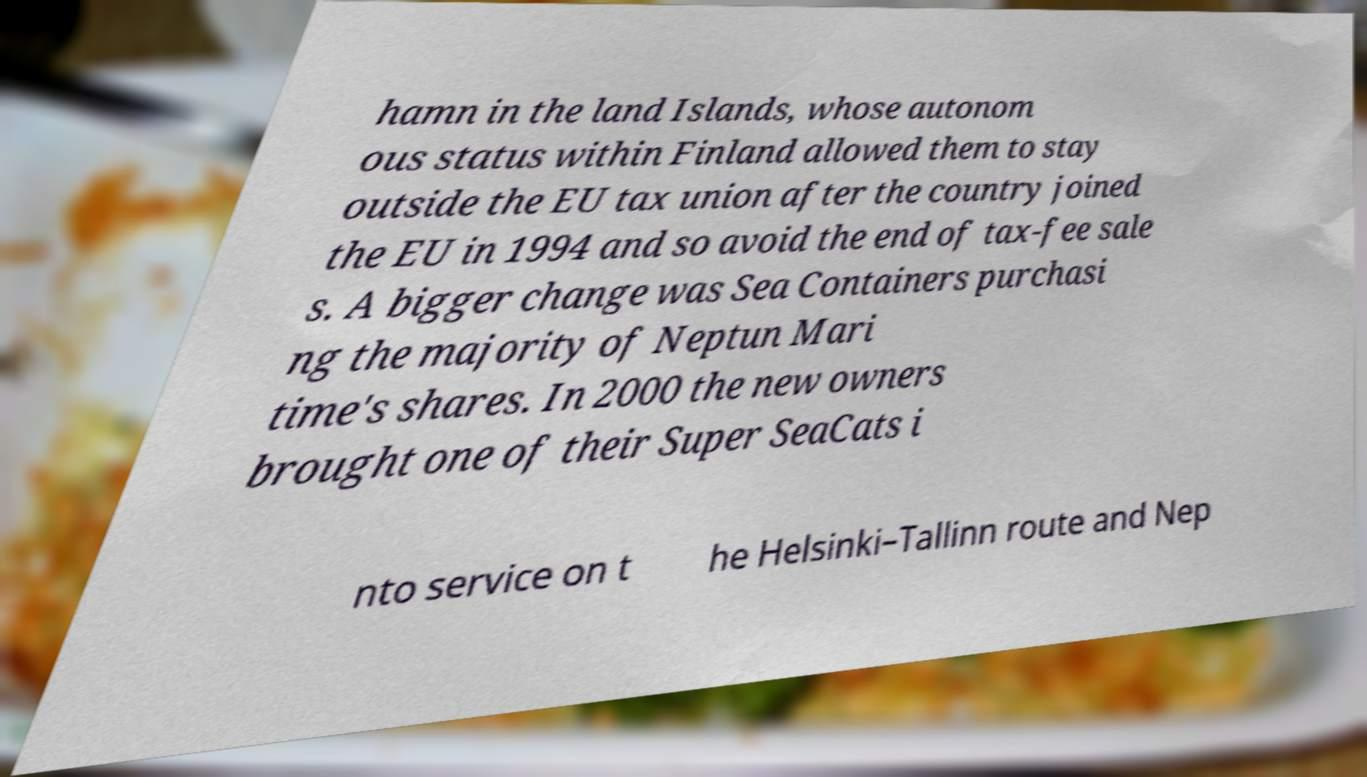Please read and relay the text visible in this image. What does it say? hamn in the land Islands, whose autonom ous status within Finland allowed them to stay outside the EU tax union after the country joined the EU in 1994 and so avoid the end of tax-fee sale s. A bigger change was Sea Containers purchasi ng the majority of Neptun Mari time's shares. In 2000 the new owners brought one of their Super SeaCats i nto service on t he Helsinki–Tallinn route and Nep 